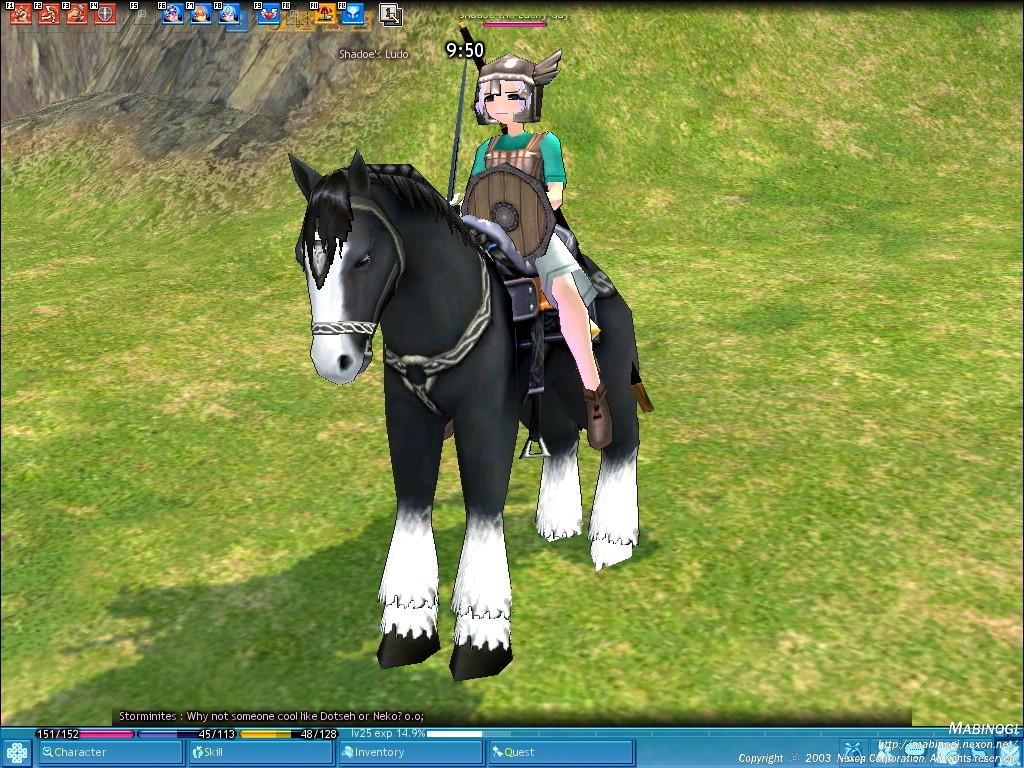What is the main subject of the image? There is a person riding a horse in the image. What can be seen in the background of the image? There is grass, rocks, logos, and text in the background of the image. How many cherries can be seen on the horse's saddle in the image? There are no cherries present in the image, and therefore no such detail can be observed. 